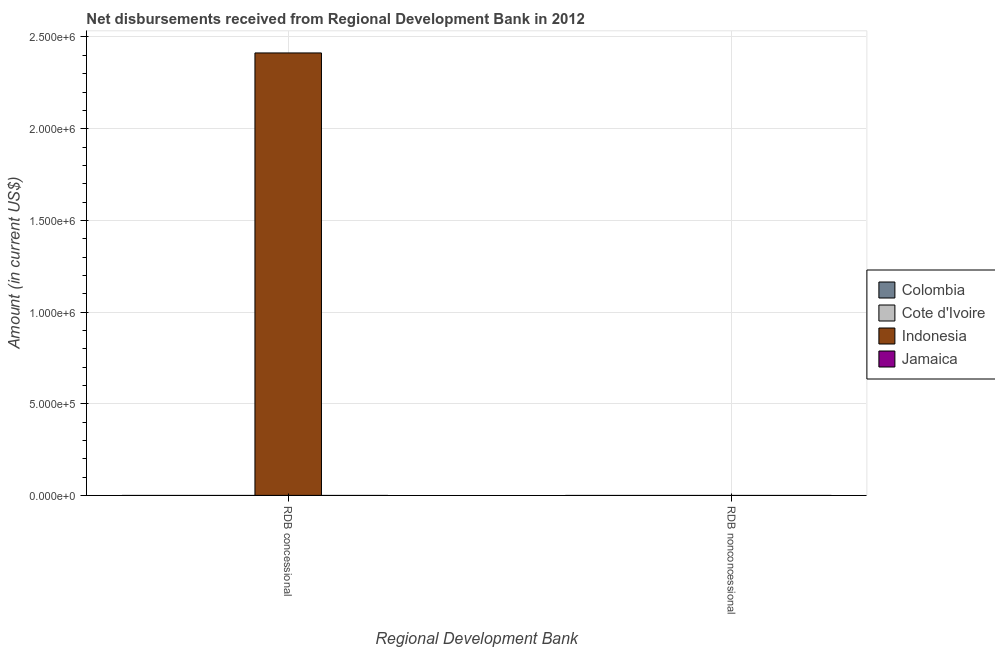Are the number of bars per tick equal to the number of legend labels?
Ensure brevity in your answer.  No. Are the number of bars on each tick of the X-axis equal?
Your answer should be compact. No. How many bars are there on the 1st tick from the right?
Your response must be concise. 0. What is the label of the 1st group of bars from the left?
Offer a very short reply. RDB concessional. Across all countries, what is the maximum net concessional disbursements from rdb?
Your answer should be compact. 2.41e+06. What is the difference between the net non concessional disbursements from rdb in Cote d'Ivoire and the net concessional disbursements from rdb in Colombia?
Your answer should be very brief. 0. What is the average net concessional disbursements from rdb per country?
Ensure brevity in your answer.  6.03e+05. In how many countries, is the net non concessional disbursements from rdb greater than the average net non concessional disbursements from rdb taken over all countries?
Your response must be concise. 0. How many bars are there?
Your answer should be compact. 1. How many countries are there in the graph?
Offer a terse response. 4. What is the difference between two consecutive major ticks on the Y-axis?
Provide a short and direct response. 5.00e+05. Does the graph contain grids?
Ensure brevity in your answer.  Yes. How are the legend labels stacked?
Make the answer very short. Vertical. What is the title of the graph?
Provide a succinct answer. Net disbursements received from Regional Development Bank in 2012. Does "Cabo Verde" appear as one of the legend labels in the graph?
Make the answer very short. No. What is the label or title of the X-axis?
Provide a succinct answer. Regional Development Bank. What is the Amount (in current US$) in Indonesia in RDB concessional?
Make the answer very short. 2.41e+06. What is the Amount (in current US$) of Colombia in RDB nonconcessional?
Give a very brief answer. 0. What is the Amount (in current US$) in Indonesia in RDB nonconcessional?
Offer a terse response. 0. Across all Regional Development Bank, what is the maximum Amount (in current US$) in Indonesia?
Offer a terse response. 2.41e+06. What is the total Amount (in current US$) in Indonesia in the graph?
Your answer should be compact. 2.41e+06. What is the average Amount (in current US$) of Colombia per Regional Development Bank?
Ensure brevity in your answer.  0. What is the average Amount (in current US$) of Indonesia per Regional Development Bank?
Provide a succinct answer. 1.21e+06. What is the difference between the highest and the lowest Amount (in current US$) in Indonesia?
Your response must be concise. 2.41e+06. 